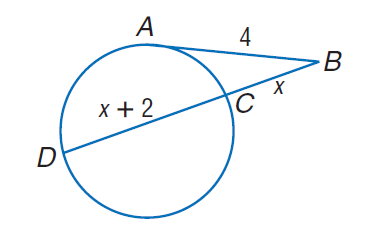Question: Find x. Assume that segments that appear to be tangent are tangent.
Choices:
A. 2
B. 2.37
C. 4
D. 4.37
Answer with the letter. Answer: B 